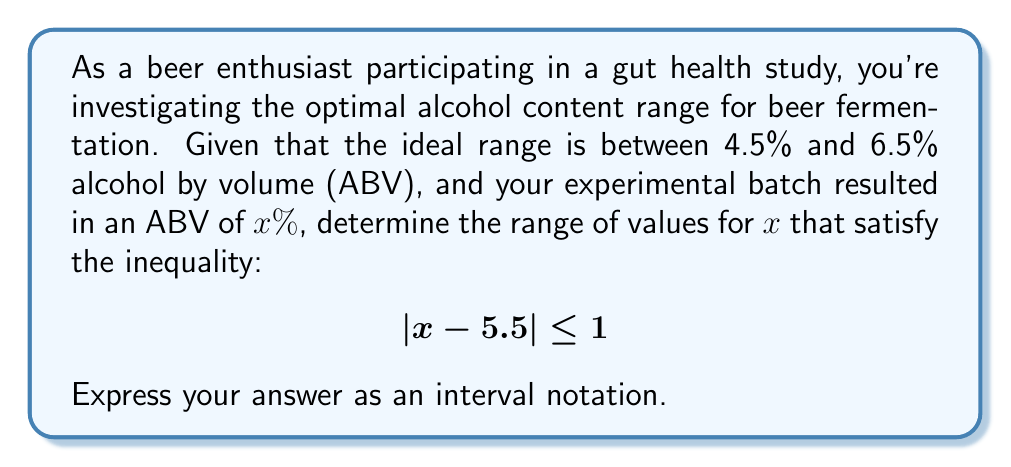Help me with this question. Let's approach this step-by-step:

1) The inequality $|x - 5.5| \leq 1$ represents the distance of $x$ from 5.5 being less than or equal to 1.

2) To solve this, we can split it into two parts:
   $-1 \leq x - 5.5 \leq 1$

3) Let's solve each side:
   For the left side: $-1 \leq x - 5.5$
   Add 5.5 to both sides: $4.5 \leq x$

   For the right side: $x - 5.5 \leq 1$
   Add 5.5 to both sides: $x \leq 6.5$

4) Combining these results, we get:
   $4.5 \leq x \leq 6.5$

5) This matches the given ideal range for beer fermentation (between 4.5% and 6.5% ABV).

6) In interval notation, this is written as $[4.5, 6.5]$.
Answer: $[4.5, 6.5]$ 